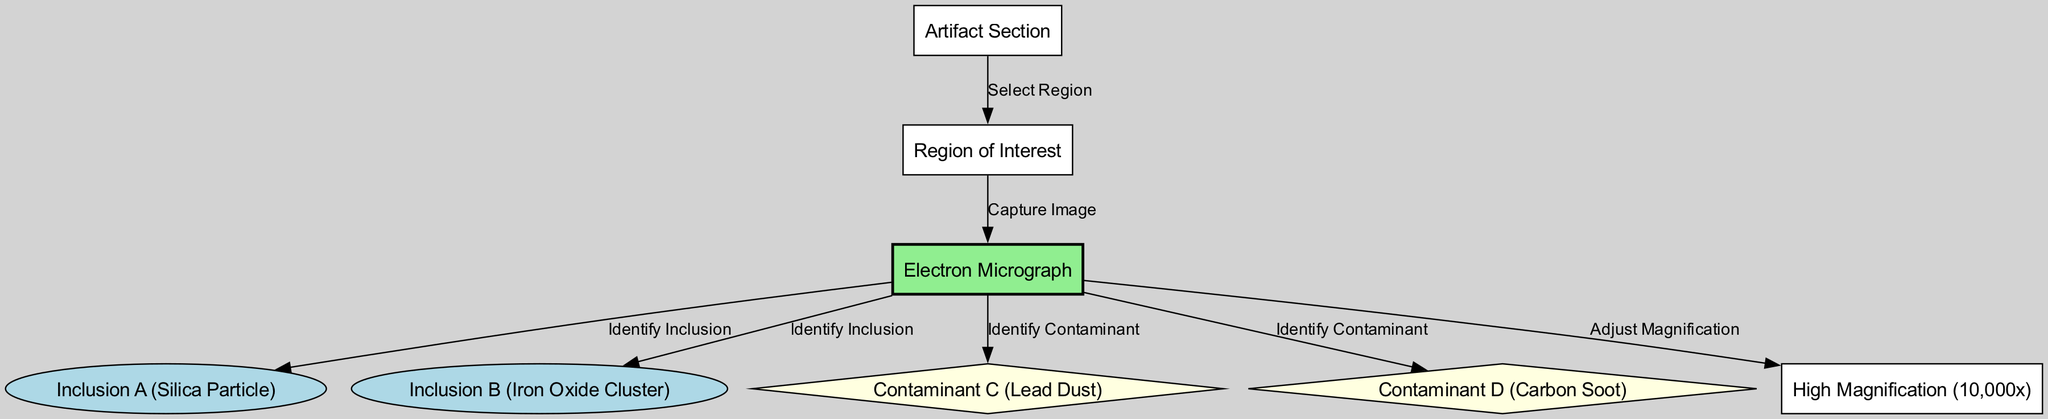What is the title of the diagram? The title of the diagram is provided at the beginning of the diagram data, which states "Electron Micrograph of Particulate Matter in Historical Artifacts."
Answer: Electron Micrograph of Particulate Matter in Historical Artifacts How many inclusions are identified in the electron micrograph? The diagram lists two inclusions with labels: "Inclusion A (Silica Particle)" and "Inclusion B (Iron Oxide Cluster)," indicating a total of two inclusions.
Answer: 2 What type of particle is Inclusion A? Inclusion A is explicitly labeled in the diagram as a "Silica Particle." This information is directly associated with the inclusion node in the diagram.
Answer: Silica Particle What is the magnification level used for the electron micrograph? The diagram specifies a magnification level of "High Magnification (10,000x)," indicating the level of detail captured in the image.
Answer: 10,000x What relationship exists between the artifact section and the region of interest? The diagram depicts an edge labeled "Select Region," which indicates that the artifact section leads to the selection of a region of interest for further analysis.
Answer: Select Region Which contaminant is associated with lead dust? In the diagram, "Contaminant C" is specifically labeled as "Lead Dust," denoting its identity as a contaminant found in the analysis.
Answer: Lead Dust What action follows after capturing the electron micrograph? After the electron micrograph is captured, the next identified action in the diagram is to "Identify Inclusion," which involves analyzing components seen in the electron micrograph.
Answer: Identify Inclusion Which two contaminants are identified in the electron micrograph? The diagram identifies two contaminants: "Contaminant C (Lead Dust)" and "Contaminant D (Carbon Soot)," both of which are labeled as contaminants in the micrograph.
Answer: Lead Dust, Carbon Soot What is the primary purpose of selecting a region in the artifact section? The primary purpose is to capture an image of the region of interest, as indicated by the edge labeled "Capture Image" that follows after selecting the region.
Answer: Capture Image 